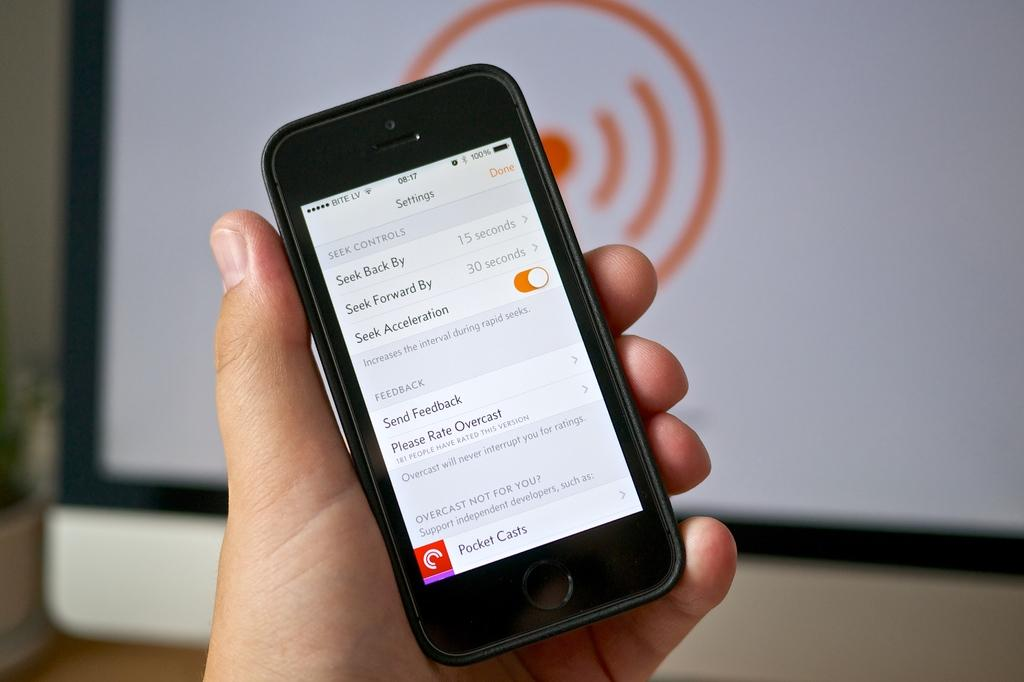Provide a one-sentence caption for the provided image. A mobile phone showing the settings screen for the Overcast application. 